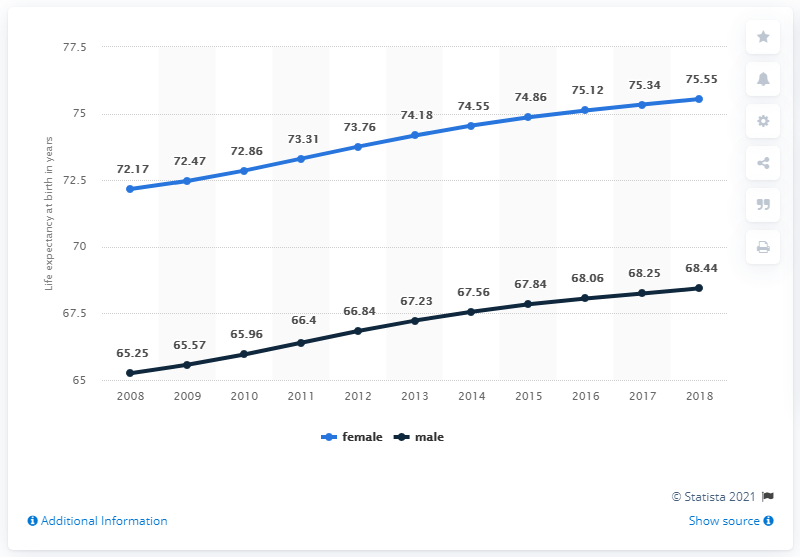Give some essential details in this illustration. In 2018, the black line graph reached its highest peak. The difference between the highest percentage and lowest percentage of the black line graph is 3.19. 